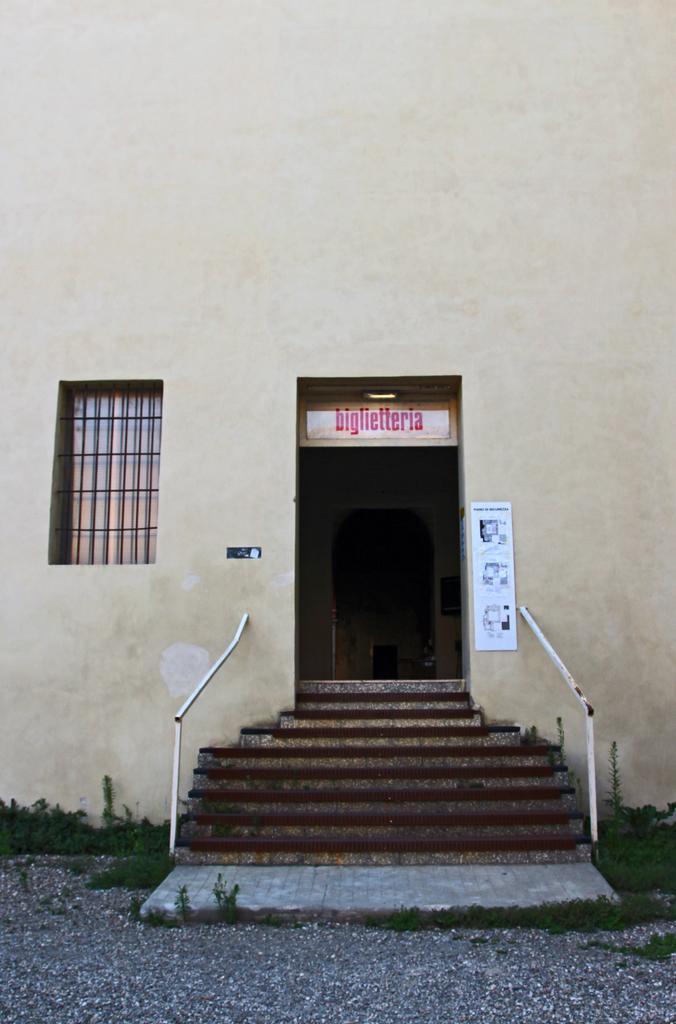Please provide a concise description of this image. Here I can see a door and a window to a wall. In front of this door there are few stairs and hand-railings. At the bottom, I can see the ground. Beside the door there is a poster attached to the wall. 